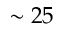<formula> <loc_0><loc_0><loc_500><loc_500>\sim 2 5</formula> 